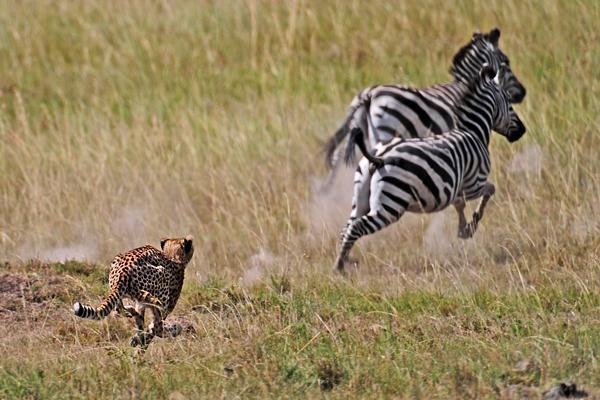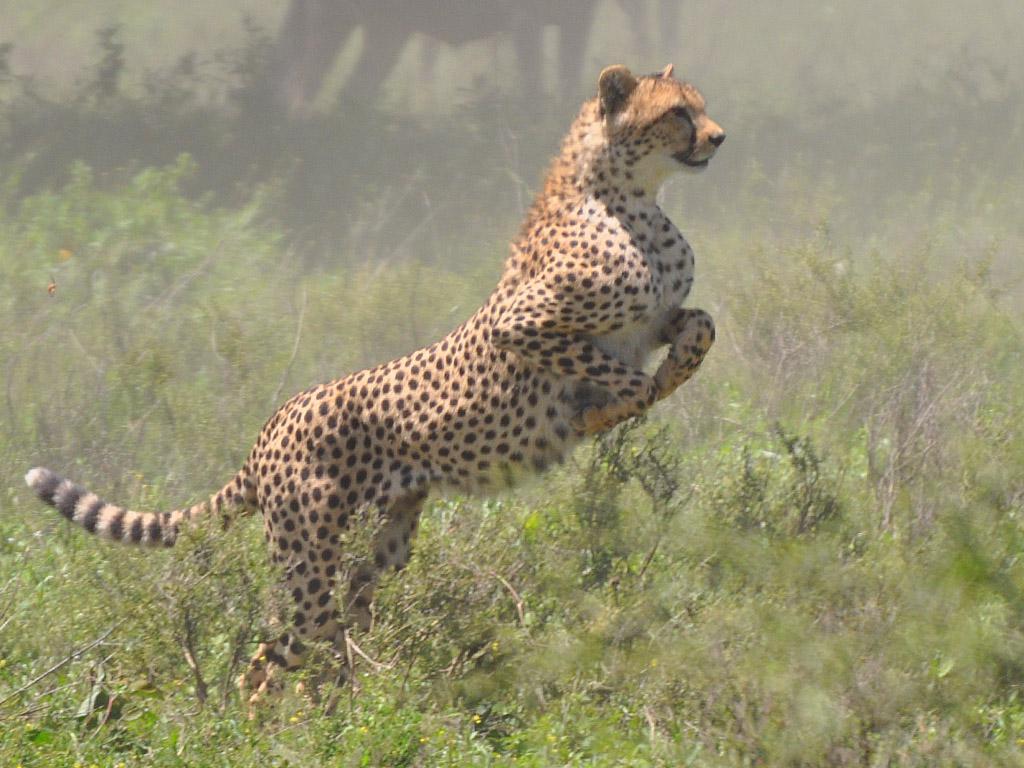The first image is the image on the left, the second image is the image on the right. Analyze the images presented: Is the assertion "One image shows a single cheetah behind at least one zebra and bounding rightward across the field towards the zebra." valid? Answer yes or no. Yes. The first image is the image on the left, the second image is the image on the right. Examine the images to the left and right. Is the description "A lone cheetah can be seen chasing at least one zebra." accurate? Answer yes or no. Yes. 